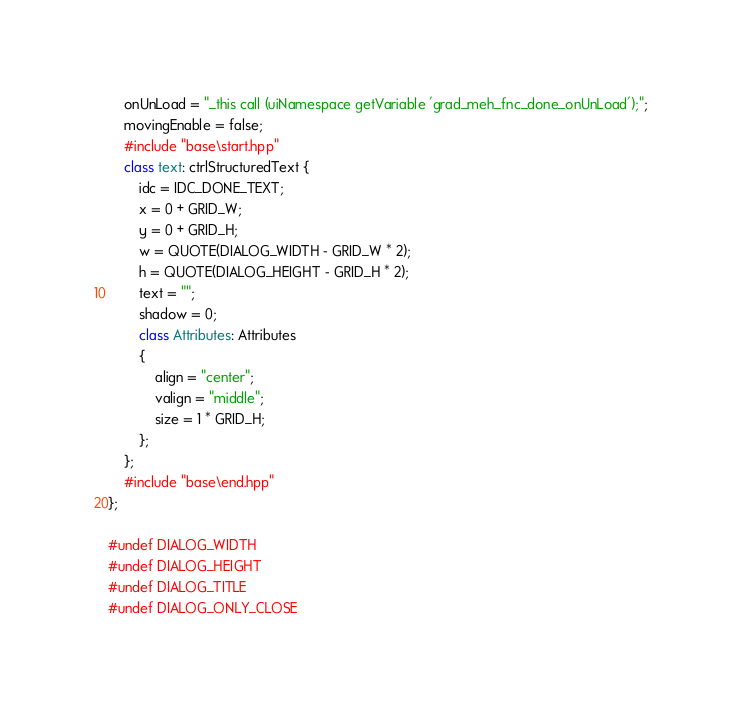<code> <loc_0><loc_0><loc_500><loc_500><_C++_>	onUnLoad = "_this call (uiNamespace getVariable 'grad_meh_fnc_done_onUnLoad');";
	movingEnable = false;
	#include "base\start.hpp"
	class text: ctrlStructuredText {
		idc = IDC_DONE_TEXT;
		x = 0 + GRID_W;
		y = 0 + GRID_H;
		w = QUOTE(DIALOG_WIDTH - GRID_W * 2);
		h = QUOTE(DIALOG_HEIGHT - GRID_H * 2);
		text = "";
		shadow = 0;
		class Attributes: Attributes
		{
			align = "center";
			valign = "middle";
			size = 1 * GRID_H;
		};
	};
	#include "base\end.hpp"
};

#undef DIALOG_WIDTH
#undef DIALOG_HEIGHT
#undef DIALOG_TITLE
#undef DIALOG_ONLY_CLOSE
</code> 